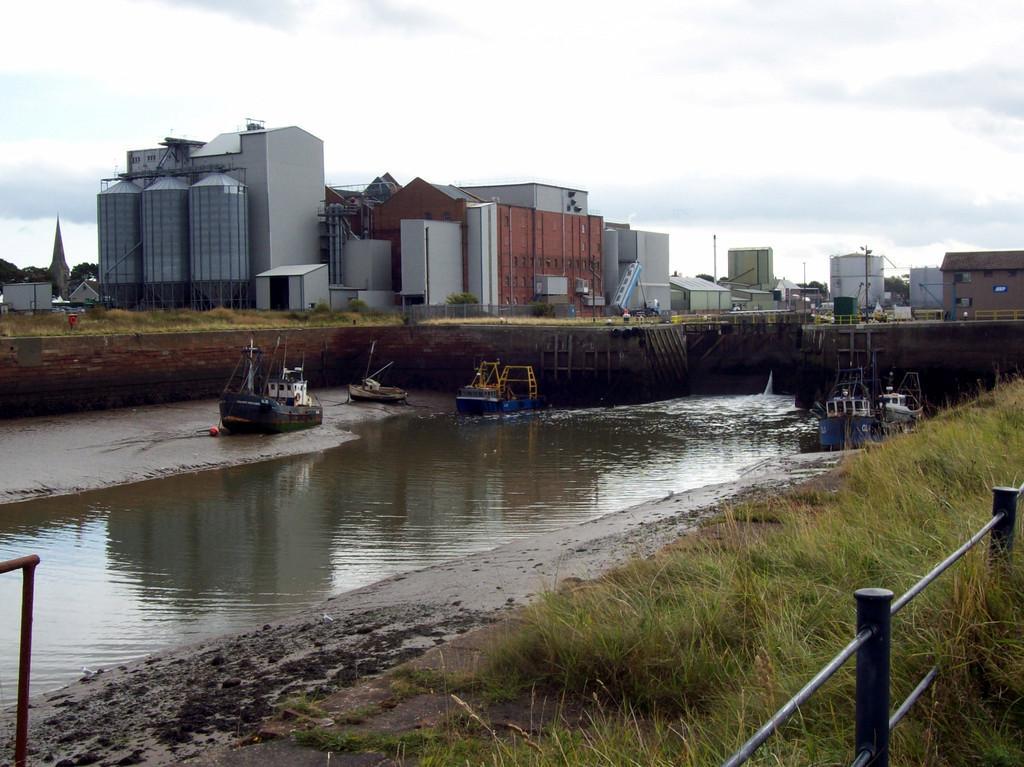Describe this image in one or two sentences. As we can see in the image there is water, grass, boats, buildings and sky. 